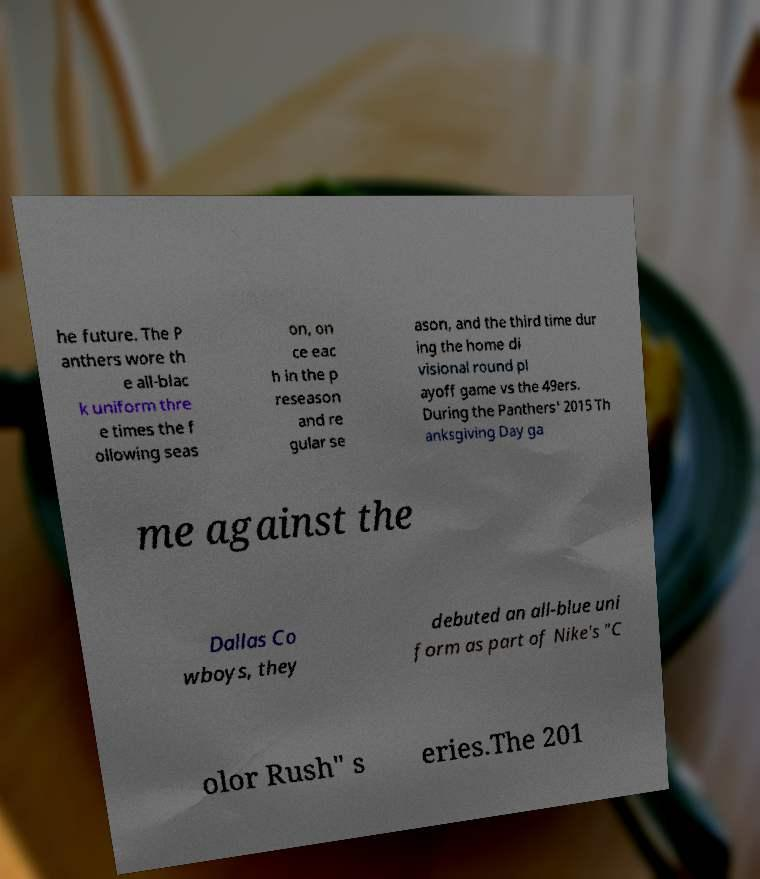There's text embedded in this image that I need extracted. Can you transcribe it verbatim? he future. The P anthers wore th e all-blac k uniform thre e times the f ollowing seas on, on ce eac h in the p reseason and re gular se ason, and the third time dur ing the home di visional round pl ayoff game vs the 49ers. During the Panthers' 2015 Th anksgiving Day ga me against the Dallas Co wboys, they debuted an all-blue uni form as part of Nike's "C olor Rush" s eries.The 201 